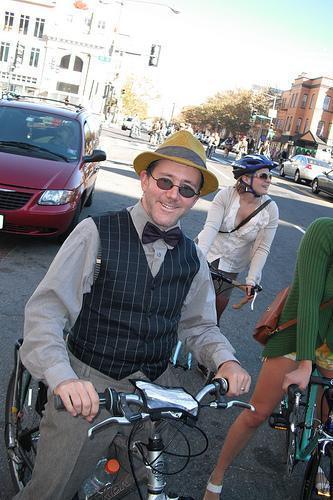How many people are wearing glasses?
Give a very brief answer. 2. 